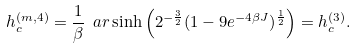Convert formula to latex. <formula><loc_0><loc_0><loc_500><loc_500>h _ { c } ^ { ( m , 4 ) } = \frac { 1 } { \beta } \ a r \sinh \left ( 2 ^ { - \frac { 3 } { 2 } } ( 1 - 9 e ^ { - 4 \beta J } ) ^ { \frac { 1 } { 2 } } \right ) = h _ { c } ^ { ( 3 ) } .</formula> 